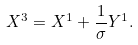Convert formula to latex. <formula><loc_0><loc_0><loc_500><loc_500>X ^ { 3 } = X ^ { 1 } + \frac { 1 } { \sigma } Y ^ { 1 } .</formula> 